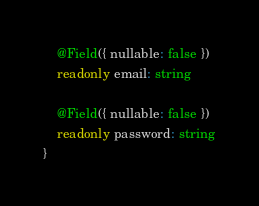<code> <loc_0><loc_0><loc_500><loc_500><_TypeScript_>
	@Field({ nullable: false })
	readonly email: string

	@Field({ nullable: false })
	readonly password: string
}</code> 